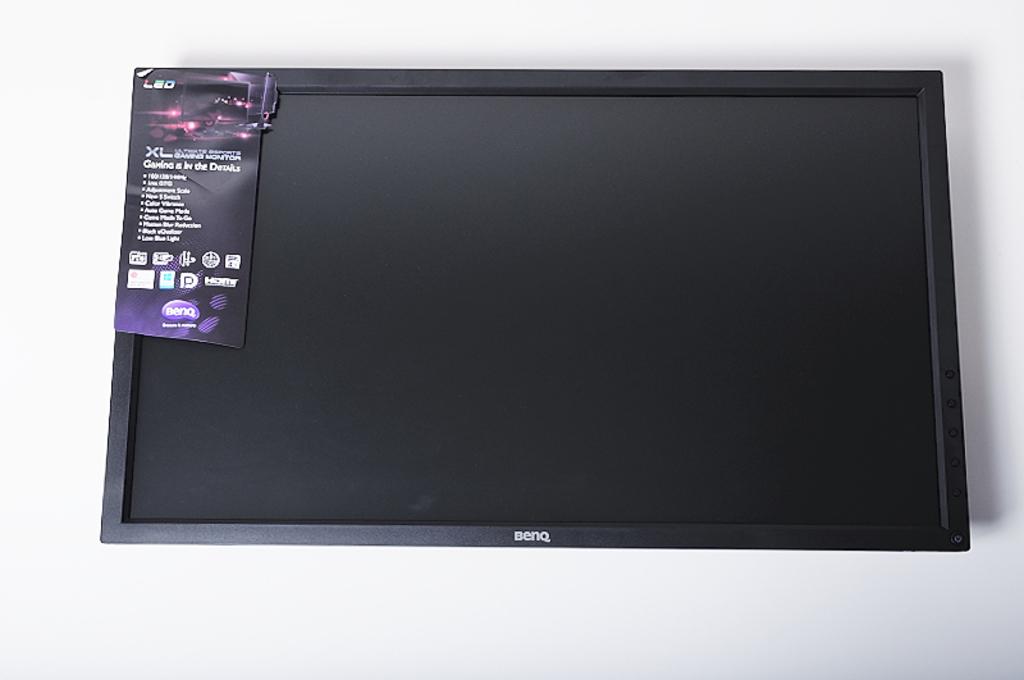What is that screen?
Keep it short and to the point. Led. What brand is the monitor?
Your answer should be compact. Benq. 